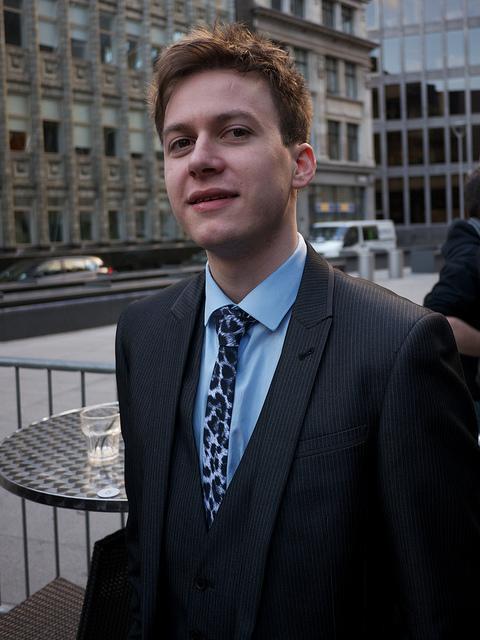How many glasses are sitting on the table?
Give a very brief answer. 1. How many cars are there in the picture?
Give a very brief answer. 2. How many donuts do you see?
Give a very brief answer. 0. 